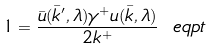Convert formula to latex. <formula><loc_0><loc_0><loc_500><loc_500>1 = \frac { \bar { u } ( \bar { k } ^ { \prime } , \lambda ) \gamma ^ { + } u ( \bar { k } , \lambda ) } { 2 k ^ { + } } \ e q p t</formula> 